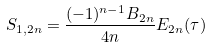<formula> <loc_0><loc_0><loc_500><loc_500>S _ { 1 , { 2 n } } = \frac { ( - 1 ) ^ { n - 1 } B _ { 2 n } } { 4 n } E _ { 2 n } ( \tau )</formula> 